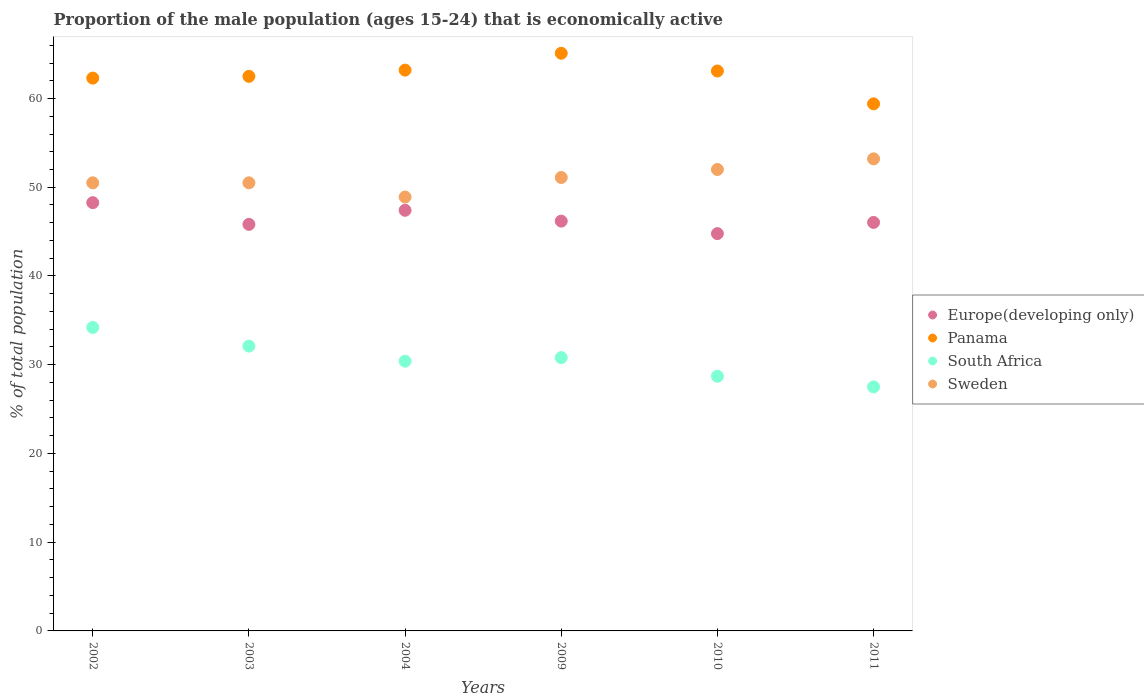What is the proportion of the male population that is economically active in South Africa in 2003?
Provide a short and direct response. 32.1. Across all years, what is the maximum proportion of the male population that is economically active in Panama?
Your response must be concise. 65.1. Across all years, what is the minimum proportion of the male population that is economically active in Sweden?
Provide a short and direct response. 48.9. In which year was the proportion of the male population that is economically active in Europe(developing only) maximum?
Ensure brevity in your answer.  2002. What is the total proportion of the male population that is economically active in Europe(developing only) in the graph?
Make the answer very short. 278.48. What is the difference between the proportion of the male population that is economically active in Panama in 2002 and that in 2010?
Your answer should be very brief. -0.8. What is the difference between the proportion of the male population that is economically active in Panama in 2011 and the proportion of the male population that is economically active in Sweden in 2009?
Provide a short and direct response. 8.3. What is the average proportion of the male population that is economically active in Europe(developing only) per year?
Your answer should be very brief. 46.41. In the year 2004, what is the difference between the proportion of the male population that is economically active in Europe(developing only) and proportion of the male population that is economically active in South Africa?
Ensure brevity in your answer.  17. In how many years, is the proportion of the male population that is economically active in Sweden greater than 54 %?
Provide a succinct answer. 0. What is the ratio of the proportion of the male population that is economically active in Sweden in 2004 to that in 2010?
Provide a succinct answer. 0.94. Is the proportion of the male population that is economically active in Panama in 2003 less than that in 2009?
Your response must be concise. Yes. What is the difference between the highest and the second highest proportion of the male population that is economically active in Panama?
Keep it short and to the point. 1.9. What is the difference between the highest and the lowest proportion of the male population that is economically active in Panama?
Provide a short and direct response. 5.7. Is the sum of the proportion of the male population that is economically active in South Africa in 2003 and 2004 greater than the maximum proportion of the male population that is economically active in Europe(developing only) across all years?
Provide a short and direct response. Yes. Is it the case that in every year, the sum of the proportion of the male population that is economically active in Panama and proportion of the male population that is economically active in Europe(developing only)  is greater than the sum of proportion of the male population that is economically active in South Africa and proportion of the male population that is economically active in Sweden?
Your response must be concise. Yes. Is the proportion of the male population that is economically active in South Africa strictly greater than the proportion of the male population that is economically active in Europe(developing only) over the years?
Provide a succinct answer. No. What is the difference between two consecutive major ticks on the Y-axis?
Your response must be concise. 10. Does the graph contain any zero values?
Give a very brief answer. No. Does the graph contain grids?
Offer a terse response. No. How many legend labels are there?
Your answer should be compact. 4. How are the legend labels stacked?
Keep it short and to the point. Vertical. What is the title of the graph?
Offer a terse response. Proportion of the male population (ages 15-24) that is economically active. Does "Afghanistan" appear as one of the legend labels in the graph?
Offer a terse response. No. What is the label or title of the X-axis?
Your answer should be very brief. Years. What is the label or title of the Y-axis?
Your response must be concise. % of total population. What is the % of total population of Europe(developing only) in 2002?
Your answer should be compact. 48.26. What is the % of total population in Panama in 2002?
Provide a short and direct response. 62.3. What is the % of total population in South Africa in 2002?
Your response must be concise. 34.2. What is the % of total population of Sweden in 2002?
Provide a short and direct response. 50.5. What is the % of total population in Europe(developing only) in 2003?
Offer a terse response. 45.82. What is the % of total population of Panama in 2003?
Keep it short and to the point. 62.5. What is the % of total population in South Africa in 2003?
Your answer should be very brief. 32.1. What is the % of total population of Sweden in 2003?
Ensure brevity in your answer.  50.5. What is the % of total population in Europe(developing only) in 2004?
Your answer should be very brief. 47.4. What is the % of total population of Panama in 2004?
Ensure brevity in your answer.  63.2. What is the % of total population of South Africa in 2004?
Your response must be concise. 30.4. What is the % of total population in Sweden in 2004?
Offer a terse response. 48.9. What is the % of total population of Europe(developing only) in 2009?
Keep it short and to the point. 46.18. What is the % of total population in Panama in 2009?
Ensure brevity in your answer.  65.1. What is the % of total population in South Africa in 2009?
Provide a succinct answer. 30.8. What is the % of total population in Sweden in 2009?
Offer a very short reply. 51.1. What is the % of total population in Europe(developing only) in 2010?
Ensure brevity in your answer.  44.77. What is the % of total population in Panama in 2010?
Offer a terse response. 63.1. What is the % of total population in South Africa in 2010?
Make the answer very short. 28.7. What is the % of total population in Sweden in 2010?
Provide a short and direct response. 52. What is the % of total population in Europe(developing only) in 2011?
Offer a terse response. 46.04. What is the % of total population of Panama in 2011?
Offer a terse response. 59.4. What is the % of total population in Sweden in 2011?
Give a very brief answer. 53.2. Across all years, what is the maximum % of total population of Europe(developing only)?
Your answer should be very brief. 48.26. Across all years, what is the maximum % of total population in Panama?
Your answer should be compact. 65.1. Across all years, what is the maximum % of total population of South Africa?
Give a very brief answer. 34.2. Across all years, what is the maximum % of total population in Sweden?
Your answer should be very brief. 53.2. Across all years, what is the minimum % of total population of Europe(developing only)?
Provide a short and direct response. 44.77. Across all years, what is the minimum % of total population in Panama?
Make the answer very short. 59.4. Across all years, what is the minimum % of total population in Sweden?
Ensure brevity in your answer.  48.9. What is the total % of total population of Europe(developing only) in the graph?
Give a very brief answer. 278.48. What is the total % of total population of Panama in the graph?
Keep it short and to the point. 375.6. What is the total % of total population in South Africa in the graph?
Your answer should be very brief. 183.7. What is the total % of total population in Sweden in the graph?
Your response must be concise. 306.2. What is the difference between the % of total population in Europe(developing only) in 2002 and that in 2003?
Your answer should be compact. 2.45. What is the difference between the % of total population in Panama in 2002 and that in 2003?
Give a very brief answer. -0.2. What is the difference between the % of total population in South Africa in 2002 and that in 2003?
Give a very brief answer. 2.1. What is the difference between the % of total population in Europe(developing only) in 2002 and that in 2004?
Your response must be concise. 0.86. What is the difference between the % of total population of Sweden in 2002 and that in 2004?
Provide a succinct answer. 1.6. What is the difference between the % of total population in Europe(developing only) in 2002 and that in 2009?
Offer a terse response. 2.08. What is the difference between the % of total population of South Africa in 2002 and that in 2009?
Make the answer very short. 3.4. What is the difference between the % of total population in Sweden in 2002 and that in 2009?
Keep it short and to the point. -0.6. What is the difference between the % of total population in Europe(developing only) in 2002 and that in 2010?
Your answer should be compact. 3.49. What is the difference between the % of total population of Panama in 2002 and that in 2010?
Offer a very short reply. -0.8. What is the difference between the % of total population of South Africa in 2002 and that in 2010?
Offer a very short reply. 5.5. What is the difference between the % of total population in Sweden in 2002 and that in 2010?
Provide a succinct answer. -1.5. What is the difference between the % of total population in Europe(developing only) in 2002 and that in 2011?
Your answer should be very brief. 2.23. What is the difference between the % of total population in Panama in 2002 and that in 2011?
Give a very brief answer. 2.9. What is the difference between the % of total population of South Africa in 2002 and that in 2011?
Make the answer very short. 6.7. What is the difference between the % of total population of Sweden in 2002 and that in 2011?
Provide a short and direct response. -2.7. What is the difference between the % of total population of Europe(developing only) in 2003 and that in 2004?
Your answer should be very brief. -1.59. What is the difference between the % of total population in Panama in 2003 and that in 2004?
Offer a very short reply. -0.7. What is the difference between the % of total population of Europe(developing only) in 2003 and that in 2009?
Your answer should be compact. -0.37. What is the difference between the % of total population in Panama in 2003 and that in 2009?
Make the answer very short. -2.6. What is the difference between the % of total population of South Africa in 2003 and that in 2009?
Provide a succinct answer. 1.3. What is the difference between the % of total population of Europe(developing only) in 2003 and that in 2010?
Offer a terse response. 1.04. What is the difference between the % of total population in South Africa in 2003 and that in 2010?
Offer a very short reply. 3.4. What is the difference between the % of total population of Europe(developing only) in 2003 and that in 2011?
Keep it short and to the point. -0.22. What is the difference between the % of total population of Sweden in 2003 and that in 2011?
Give a very brief answer. -2.7. What is the difference between the % of total population in Europe(developing only) in 2004 and that in 2009?
Offer a very short reply. 1.22. What is the difference between the % of total population of Panama in 2004 and that in 2009?
Your response must be concise. -1.9. What is the difference between the % of total population in South Africa in 2004 and that in 2009?
Give a very brief answer. -0.4. What is the difference between the % of total population in Sweden in 2004 and that in 2009?
Give a very brief answer. -2.2. What is the difference between the % of total population in Europe(developing only) in 2004 and that in 2010?
Make the answer very short. 2.63. What is the difference between the % of total population in South Africa in 2004 and that in 2010?
Your response must be concise. 1.7. What is the difference between the % of total population in Europe(developing only) in 2004 and that in 2011?
Provide a succinct answer. 1.37. What is the difference between the % of total population of Panama in 2004 and that in 2011?
Your response must be concise. 3.8. What is the difference between the % of total population of Sweden in 2004 and that in 2011?
Ensure brevity in your answer.  -4.3. What is the difference between the % of total population of Europe(developing only) in 2009 and that in 2010?
Make the answer very short. 1.41. What is the difference between the % of total population in South Africa in 2009 and that in 2010?
Make the answer very short. 2.1. What is the difference between the % of total population of Europe(developing only) in 2009 and that in 2011?
Your answer should be very brief. 0.15. What is the difference between the % of total population of Panama in 2009 and that in 2011?
Provide a short and direct response. 5.7. What is the difference between the % of total population of South Africa in 2009 and that in 2011?
Offer a very short reply. 3.3. What is the difference between the % of total population of Europe(developing only) in 2010 and that in 2011?
Make the answer very short. -1.26. What is the difference between the % of total population of South Africa in 2010 and that in 2011?
Provide a short and direct response. 1.2. What is the difference between the % of total population of Europe(developing only) in 2002 and the % of total population of Panama in 2003?
Provide a short and direct response. -14.24. What is the difference between the % of total population of Europe(developing only) in 2002 and the % of total population of South Africa in 2003?
Your answer should be very brief. 16.16. What is the difference between the % of total population of Europe(developing only) in 2002 and the % of total population of Sweden in 2003?
Your response must be concise. -2.24. What is the difference between the % of total population of Panama in 2002 and the % of total population of South Africa in 2003?
Provide a succinct answer. 30.2. What is the difference between the % of total population of Panama in 2002 and the % of total population of Sweden in 2003?
Keep it short and to the point. 11.8. What is the difference between the % of total population of South Africa in 2002 and the % of total population of Sweden in 2003?
Your response must be concise. -16.3. What is the difference between the % of total population in Europe(developing only) in 2002 and the % of total population in Panama in 2004?
Ensure brevity in your answer.  -14.94. What is the difference between the % of total population in Europe(developing only) in 2002 and the % of total population in South Africa in 2004?
Ensure brevity in your answer.  17.86. What is the difference between the % of total population of Europe(developing only) in 2002 and the % of total population of Sweden in 2004?
Give a very brief answer. -0.64. What is the difference between the % of total population of Panama in 2002 and the % of total population of South Africa in 2004?
Provide a succinct answer. 31.9. What is the difference between the % of total population of South Africa in 2002 and the % of total population of Sweden in 2004?
Keep it short and to the point. -14.7. What is the difference between the % of total population in Europe(developing only) in 2002 and the % of total population in Panama in 2009?
Your answer should be very brief. -16.84. What is the difference between the % of total population in Europe(developing only) in 2002 and the % of total population in South Africa in 2009?
Keep it short and to the point. 17.46. What is the difference between the % of total population in Europe(developing only) in 2002 and the % of total population in Sweden in 2009?
Your response must be concise. -2.84. What is the difference between the % of total population in Panama in 2002 and the % of total population in South Africa in 2009?
Offer a terse response. 31.5. What is the difference between the % of total population of Panama in 2002 and the % of total population of Sweden in 2009?
Give a very brief answer. 11.2. What is the difference between the % of total population in South Africa in 2002 and the % of total population in Sweden in 2009?
Make the answer very short. -16.9. What is the difference between the % of total population of Europe(developing only) in 2002 and the % of total population of Panama in 2010?
Your response must be concise. -14.84. What is the difference between the % of total population in Europe(developing only) in 2002 and the % of total population in South Africa in 2010?
Offer a terse response. 19.56. What is the difference between the % of total population in Europe(developing only) in 2002 and the % of total population in Sweden in 2010?
Keep it short and to the point. -3.74. What is the difference between the % of total population in Panama in 2002 and the % of total population in South Africa in 2010?
Keep it short and to the point. 33.6. What is the difference between the % of total population of Panama in 2002 and the % of total population of Sweden in 2010?
Give a very brief answer. 10.3. What is the difference between the % of total population of South Africa in 2002 and the % of total population of Sweden in 2010?
Your response must be concise. -17.8. What is the difference between the % of total population of Europe(developing only) in 2002 and the % of total population of Panama in 2011?
Your answer should be very brief. -11.14. What is the difference between the % of total population in Europe(developing only) in 2002 and the % of total population in South Africa in 2011?
Ensure brevity in your answer.  20.76. What is the difference between the % of total population in Europe(developing only) in 2002 and the % of total population in Sweden in 2011?
Your response must be concise. -4.94. What is the difference between the % of total population of Panama in 2002 and the % of total population of South Africa in 2011?
Offer a very short reply. 34.8. What is the difference between the % of total population of Europe(developing only) in 2003 and the % of total population of Panama in 2004?
Offer a terse response. -17.38. What is the difference between the % of total population of Europe(developing only) in 2003 and the % of total population of South Africa in 2004?
Make the answer very short. 15.42. What is the difference between the % of total population in Europe(developing only) in 2003 and the % of total population in Sweden in 2004?
Offer a terse response. -3.08. What is the difference between the % of total population of Panama in 2003 and the % of total population of South Africa in 2004?
Offer a terse response. 32.1. What is the difference between the % of total population of Panama in 2003 and the % of total population of Sweden in 2004?
Offer a terse response. 13.6. What is the difference between the % of total population of South Africa in 2003 and the % of total population of Sweden in 2004?
Provide a short and direct response. -16.8. What is the difference between the % of total population of Europe(developing only) in 2003 and the % of total population of Panama in 2009?
Ensure brevity in your answer.  -19.28. What is the difference between the % of total population in Europe(developing only) in 2003 and the % of total population in South Africa in 2009?
Make the answer very short. 15.02. What is the difference between the % of total population in Europe(developing only) in 2003 and the % of total population in Sweden in 2009?
Provide a succinct answer. -5.28. What is the difference between the % of total population in Panama in 2003 and the % of total population in South Africa in 2009?
Your answer should be compact. 31.7. What is the difference between the % of total population in Panama in 2003 and the % of total population in Sweden in 2009?
Provide a short and direct response. 11.4. What is the difference between the % of total population in South Africa in 2003 and the % of total population in Sweden in 2009?
Your answer should be compact. -19. What is the difference between the % of total population in Europe(developing only) in 2003 and the % of total population in Panama in 2010?
Your response must be concise. -17.28. What is the difference between the % of total population of Europe(developing only) in 2003 and the % of total population of South Africa in 2010?
Your response must be concise. 17.12. What is the difference between the % of total population of Europe(developing only) in 2003 and the % of total population of Sweden in 2010?
Your answer should be very brief. -6.18. What is the difference between the % of total population in Panama in 2003 and the % of total population in South Africa in 2010?
Make the answer very short. 33.8. What is the difference between the % of total population in Panama in 2003 and the % of total population in Sweden in 2010?
Your answer should be very brief. 10.5. What is the difference between the % of total population of South Africa in 2003 and the % of total population of Sweden in 2010?
Offer a very short reply. -19.9. What is the difference between the % of total population in Europe(developing only) in 2003 and the % of total population in Panama in 2011?
Your answer should be very brief. -13.58. What is the difference between the % of total population in Europe(developing only) in 2003 and the % of total population in South Africa in 2011?
Give a very brief answer. 18.32. What is the difference between the % of total population in Europe(developing only) in 2003 and the % of total population in Sweden in 2011?
Your answer should be very brief. -7.38. What is the difference between the % of total population of Panama in 2003 and the % of total population of South Africa in 2011?
Offer a terse response. 35. What is the difference between the % of total population in South Africa in 2003 and the % of total population in Sweden in 2011?
Provide a short and direct response. -21.1. What is the difference between the % of total population in Europe(developing only) in 2004 and the % of total population in Panama in 2009?
Provide a short and direct response. -17.7. What is the difference between the % of total population of Europe(developing only) in 2004 and the % of total population of South Africa in 2009?
Offer a very short reply. 16.6. What is the difference between the % of total population of Europe(developing only) in 2004 and the % of total population of Sweden in 2009?
Your answer should be very brief. -3.7. What is the difference between the % of total population in Panama in 2004 and the % of total population in South Africa in 2009?
Your answer should be compact. 32.4. What is the difference between the % of total population of Panama in 2004 and the % of total population of Sweden in 2009?
Your answer should be compact. 12.1. What is the difference between the % of total population in South Africa in 2004 and the % of total population in Sweden in 2009?
Offer a terse response. -20.7. What is the difference between the % of total population of Europe(developing only) in 2004 and the % of total population of Panama in 2010?
Make the answer very short. -15.7. What is the difference between the % of total population of Europe(developing only) in 2004 and the % of total population of South Africa in 2010?
Make the answer very short. 18.7. What is the difference between the % of total population in Europe(developing only) in 2004 and the % of total population in Sweden in 2010?
Make the answer very short. -4.6. What is the difference between the % of total population of Panama in 2004 and the % of total population of South Africa in 2010?
Offer a terse response. 34.5. What is the difference between the % of total population of Panama in 2004 and the % of total population of Sweden in 2010?
Your answer should be very brief. 11.2. What is the difference between the % of total population of South Africa in 2004 and the % of total population of Sweden in 2010?
Give a very brief answer. -21.6. What is the difference between the % of total population of Europe(developing only) in 2004 and the % of total population of Panama in 2011?
Your answer should be very brief. -12. What is the difference between the % of total population in Europe(developing only) in 2004 and the % of total population in South Africa in 2011?
Offer a very short reply. 19.9. What is the difference between the % of total population in Europe(developing only) in 2004 and the % of total population in Sweden in 2011?
Your answer should be compact. -5.8. What is the difference between the % of total population in Panama in 2004 and the % of total population in South Africa in 2011?
Keep it short and to the point. 35.7. What is the difference between the % of total population in South Africa in 2004 and the % of total population in Sweden in 2011?
Make the answer very short. -22.8. What is the difference between the % of total population of Europe(developing only) in 2009 and the % of total population of Panama in 2010?
Offer a terse response. -16.92. What is the difference between the % of total population in Europe(developing only) in 2009 and the % of total population in South Africa in 2010?
Your answer should be compact. 17.48. What is the difference between the % of total population of Europe(developing only) in 2009 and the % of total population of Sweden in 2010?
Provide a succinct answer. -5.82. What is the difference between the % of total population in Panama in 2009 and the % of total population in South Africa in 2010?
Your answer should be very brief. 36.4. What is the difference between the % of total population of Panama in 2009 and the % of total population of Sweden in 2010?
Ensure brevity in your answer.  13.1. What is the difference between the % of total population in South Africa in 2009 and the % of total population in Sweden in 2010?
Your response must be concise. -21.2. What is the difference between the % of total population in Europe(developing only) in 2009 and the % of total population in Panama in 2011?
Give a very brief answer. -13.22. What is the difference between the % of total population in Europe(developing only) in 2009 and the % of total population in South Africa in 2011?
Provide a succinct answer. 18.68. What is the difference between the % of total population in Europe(developing only) in 2009 and the % of total population in Sweden in 2011?
Ensure brevity in your answer.  -7.02. What is the difference between the % of total population in Panama in 2009 and the % of total population in South Africa in 2011?
Ensure brevity in your answer.  37.6. What is the difference between the % of total population of Panama in 2009 and the % of total population of Sweden in 2011?
Your answer should be compact. 11.9. What is the difference between the % of total population of South Africa in 2009 and the % of total population of Sweden in 2011?
Your answer should be very brief. -22.4. What is the difference between the % of total population of Europe(developing only) in 2010 and the % of total population of Panama in 2011?
Make the answer very short. -14.63. What is the difference between the % of total population in Europe(developing only) in 2010 and the % of total population in South Africa in 2011?
Your response must be concise. 17.27. What is the difference between the % of total population of Europe(developing only) in 2010 and the % of total population of Sweden in 2011?
Your answer should be very brief. -8.43. What is the difference between the % of total population in Panama in 2010 and the % of total population in South Africa in 2011?
Your answer should be compact. 35.6. What is the difference between the % of total population in Panama in 2010 and the % of total population in Sweden in 2011?
Offer a terse response. 9.9. What is the difference between the % of total population of South Africa in 2010 and the % of total population of Sweden in 2011?
Your answer should be very brief. -24.5. What is the average % of total population in Europe(developing only) per year?
Provide a short and direct response. 46.41. What is the average % of total population in Panama per year?
Keep it short and to the point. 62.6. What is the average % of total population of South Africa per year?
Your answer should be compact. 30.62. What is the average % of total population in Sweden per year?
Provide a short and direct response. 51.03. In the year 2002, what is the difference between the % of total population in Europe(developing only) and % of total population in Panama?
Provide a short and direct response. -14.04. In the year 2002, what is the difference between the % of total population of Europe(developing only) and % of total population of South Africa?
Offer a terse response. 14.06. In the year 2002, what is the difference between the % of total population of Europe(developing only) and % of total population of Sweden?
Your response must be concise. -2.24. In the year 2002, what is the difference between the % of total population of Panama and % of total population of South Africa?
Your response must be concise. 28.1. In the year 2002, what is the difference between the % of total population of Panama and % of total population of Sweden?
Ensure brevity in your answer.  11.8. In the year 2002, what is the difference between the % of total population of South Africa and % of total population of Sweden?
Keep it short and to the point. -16.3. In the year 2003, what is the difference between the % of total population in Europe(developing only) and % of total population in Panama?
Your answer should be compact. -16.68. In the year 2003, what is the difference between the % of total population of Europe(developing only) and % of total population of South Africa?
Your response must be concise. 13.72. In the year 2003, what is the difference between the % of total population of Europe(developing only) and % of total population of Sweden?
Your response must be concise. -4.68. In the year 2003, what is the difference between the % of total population in Panama and % of total population in South Africa?
Give a very brief answer. 30.4. In the year 2003, what is the difference between the % of total population of South Africa and % of total population of Sweden?
Keep it short and to the point. -18.4. In the year 2004, what is the difference between the % of total population of Europe(developing only) and % of total population of Panama?
Your response must be concise. -15.8. In the year 2004, what is the difference between the % of total population in Europe(developing only) and % of total population in South Africa?
Make the answer very short. 17. In the year 2004, what is the difference between the % of total population in Europe(developing only) and % of total population in Sweden?
Make the answer very short. -1.5. In the year 2004, what is the difference between the % of total population of Panama and % of total population of South Africa?
Provide a succinct answer. 32.8. In the year 2004, what is the difference between the % of total population in Panama and % of total population in Sweden?
Your response must be concise. 14.3. In the year 2004, what is the difference between the % of total population in South Africa and % of total population in Sweden?
Keep it short and to the point. -18.5. In the year 2009, what is the difference between the % of total population in Europe(developing only) and % of total population in Panama?
Offer a very short reply. -18.92. In the year 2009, what is the difference between the % of total population in Europe(developing only) and % of total population in South Africa?
Your answer should be compact. 15.38. In the year 2009, what is the difference between the % of total population in Europe(developing only) and % of total population in Sweden?
Your answer should be compact. -4.92. In the year 2009, what is the difference between the % of total population in Panama and % of total population in South Africa?
Your answer should be compact. 34.3. In the year 2009, what is the difference between the % of total population of South Africa and % of total population of Sweden?
Your response must be concise. -20.3. In the year 2010, what is the difference between the % of total population in Europe(developing only) and % of total population in Panama?
Offer a terse response. -18.33. In the year 2010, what is the difference between the % of total population of Europe(developing only) and % of total population of South Africa?
Keep it short and to the point. 16.07. In the year 2010, what is the difference between the % of total population in Europe(developing only) and % of total population in Sweden?
Provide a short and direct response. -7.23. In the year 2010, what is the difference between the % of total population in Panama and % of total population in South Africa?
Make the answer very short. 34.4. In the year 2010, what is the difference between the % of total population in Panama and % of total population in Sweden?
Offer a very short reply. 11.1. In the year 2010, what is the difference between the % of total population of South Africa and % of total population of Sweden?
Give a very brief answer. -23.3. In the year 2011, what is the difference between the % of total population of Europe(developing only) and % of total population of Panama?
Ensure brevity in your answer.  -13.36. In the year 2011, what is the difference between the % of total population in Europe(developing only) and % of total population in South Africa?
Offer a very short reply. 18.54. In the year 2011, what is the difference between the % of total population in Europe(developing only) and % of total population in Sweden?
Ensure brevity in your answer.  -7.16. In the year 2011, what is the difference between the % of total population of Panama and % of total population of South Africa?
Ensure brevity in your answer.  31.9. In the year 2011, what is the difference between the % of total population of South Africa and % of total population of Sweden?
Keep it short and to the point. -25.7. What is the ratio of the % of total population of Europe(developing only) in 2002 to that in 2003?
Provide a succinct answer. 1.05. What is the ratio of the % of total population of Panama in 2002 to that in 2003?
Provide a succinct answer. 1. What is the ratio of the % of total population of South Africa in 2002 to that in 2003?
Your answer should be very brief. 1.07. What is the ratio of the % of total population in Europe(developing only) in 2002 to that in 2004?
Keep it short and to the point. 1.02. What is the ratio of the % of total population of Panama in 2002 to that in 2004?
Your response must be concise. 0.99. What is the ratio of the % of total population in South Africa in 2002 to that in 2004?
Make the answer very short. 1.12. What is the ratio of the % of total population in Sweden in 2002 to that in 2004?
Make the answer very short. 1.03. What is the ratio of the % of total population in Europe(developing only) in 2002 to that in 2009?
Make the answer very short. 1.05. What is the ratio of the % of total population in Panama in 2002 to that in 2009?
Ensure brevity in your answer.  0.96. What is the ratio of the % of total population of South Africa in 2002 to that in 2009?
Your answer should be very brief. 1.11. What is the ratio of the % of total population in Sweden in 2002 to that in 2009?
Give a very brief answer. 0.99. What is the ratio of the % of total population in Europe(developing only) in 2002 to that in 2010?
Provide a short and direct response. 1.08. What is the ratio of the % of total population of Panama in 2002 to that in 2010?
Provide a short and direct response. 0.99. What is the ratio of the % of total population of South Africa in 2002 to that in 2010?
Your answer should be compact. 1.19. What is the ratio of the % of total population in Sweden in 2002 to that in 2010?
Offer a terse response. 0.97. What is the ratio of the % of total population of Europe(developing only) in 2002 to that in 2011?
Ensure brevity in your answer.  1.05. What is the ratio of the % of total population of Panama in 2002 to that in 2011?
Keep it short and to the point. 1.05. What is the ratio of the % of total population in South Africa in 2002 to that in 2011?
Your answer should be compact. 1.24. What is the ratio of the % of total population of Sweden in 2002 to that in 2011?
Offer a very short reply. 0.95. What is the ratio of the % of total population in Europe(developing only) in 2003 to that in 2004?
Your answer should be compact. 0.97. What is the ratio of the % of total population of Panama in 2003 to that in 2004?
Provide a short and direct response. 0.99. What is the ratio of the % of total population in South Africa in 2003 to that in 2004?
Offer a very short reply. 1.06. What is the ratio of the % of total population of Sweden in 2003 to that in 2004?
Give a very brief answer. 1.03. What is the ratio of the % of total population of Panama in 2003 to that in 2009?
Provide a succinct answer. 0.96. What is the ratio of the % of total population of South Africa in 2003 to that in 2009?
Give a very brief answer. 1.04. What is the ratio of the % of total population of Sweden in 2003 to that in 2009?
Your answer should be very brief. 0.99. What is the ratio of the % of total population of Europe(developing only) in 2003 to that in 2010?
Provide a short and direct response. 1.02. What is the ratio of the % of total population in South Africa in 2003 to that in 2010?
Your response must be concise. 1.12. What is the ratio of the % of total population of Sweden in 2003 to that in 2010?
Make the answer very short. 0.97. What is the ratio of the % of total population of Panama in 2003 to that in 2011?
Keep it short and to the point. 1.05. What is the ratio of the % of total population in South Africa in 2003 to that in 2011?
Your response must be concise. 1.17. What is the ratio of the % of total population of Sweden in 2003 to that in 2011?
Give a very brief answer. 0.95. What is the ratio of the % of total population in Europe(developing only) in 2004 to that in 2009?
Provide a short and direct response. 1.03. What is the ratio of the % of total population in Panama in 2004 to that in 2009?
Your answer should be very brief. 0.97. What is the ratio of the % of total population of South Africa in 2004 to that in 2009?
Your answer should be very brief. 0.99. What is the ratio of the % of total population of Sweden in 2004 to that in 2009?
Your answer should be very brief. 0.96. What is the ratio of the % of total population of Europe(developing only) in 2004 to that in 2010?
Offer a very short reply. 1.06. What is the ratio of the % of total population of South Africa in 2004 to that in 2010?
Your response must be concise. 1.06. What is the ratio of the % of total population of Sweden in 2004 to that in 2010?
Provide a short and direct response. 0.94. What is the ratio of the % of total population in Europe(developing only) in 2004 to that in 2011?
Offer a very short reply. 1.03. What is the ratio of the % of total population in Panama in 2004 to that in 2011?
Provide a short and direct response. 1.06. What is the ratio of the % of total population of South Africa in 2004 to that in 2011?
Keep it short and to the point. 1.11. What is the ratio of the % of total population in Sweden in 2004 to that in 2011?
Offer a terse response. 0.92. What is the ratio of the % of total population of Europe(developing only) in 2009 to that in 2010?
Keep it short and to the point. 1.03. What is the ratio of the % of total population of Panama in 2009 to that in 2010?
Keep it short and to the point. 1.03. What is the ratio of the % of total population of South Africa in 2009 to that in 2010?
Make the answer very short. 1.07. What is the ratio of the % of total population in Sweden in 2009 to that in 2010?
Offer a terse response. 0.98. What is the ratio of the % of total population in Panama in 2009 to that in 2011?
Keep it short and to the point. 1.1. What is the ratio of the % of total population of South Africa in 2009 to that in 2011?
Give a very brief answer. 1.12. What is the ratio of the % of total population of Sweden in 2009 to that in 2011?
Make the answer very short. 0.96. What is the ratio of the % of total population of Europe(developing only) in 2010 to that in 2011?
Provide a succinct answer. 0.97. What is the ratio of the % of total population of Panama in 2010 to that in 2011?
Provide a succinct answer. 1.06. What is the ratio of the % of total population of South Africa in 2010 to that in 2011?
Ensure brevity in your answer.  1.04. What is the ratio of the % of total population of Sweden in 2010 to that in 2011?
Your response must be concise. 0.98. What is the difference between the highest and the second highest % of total population in Europe(developing only)?
Give a very brief answer. 0.86. What is the difference between the highest and the second highest % of total population of Panama?
Provide a short and direct response. 1.9. What is the difference between the highest and the second highest % of total population in South Africa?
Provide a short and direct response. 2.1. What is the difference between the highest and the lowest % of total population in Europe(developing only)?
Your response must be concise. 3.49. What is the difference between the highest and the lowest % of total population of Sweden?
Provide a succinct answer. 4.3. 